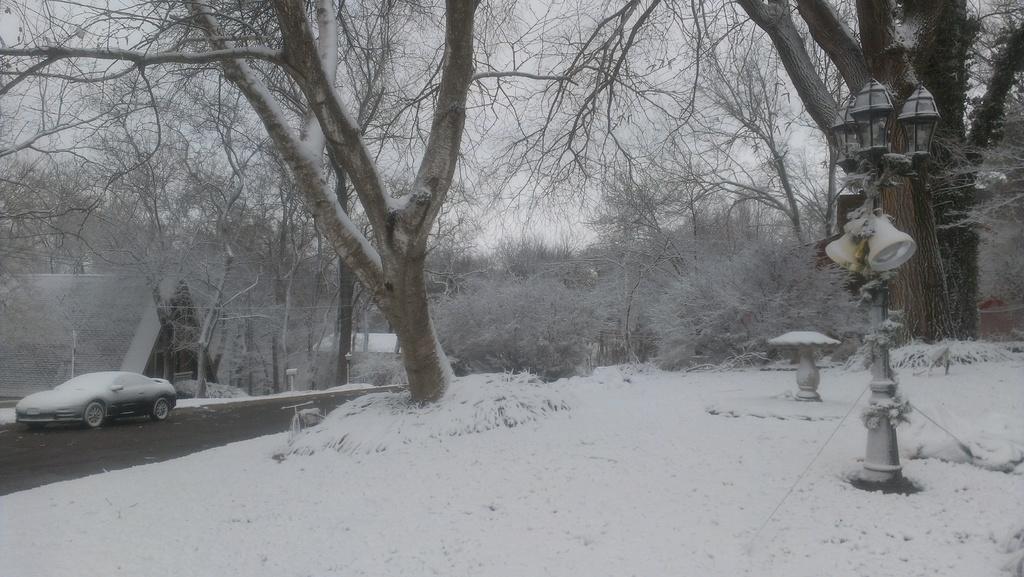In one or two sentences, can you explain what this image depicts? As we can see in the image there is snow, trees, road, car, houses and sky. 